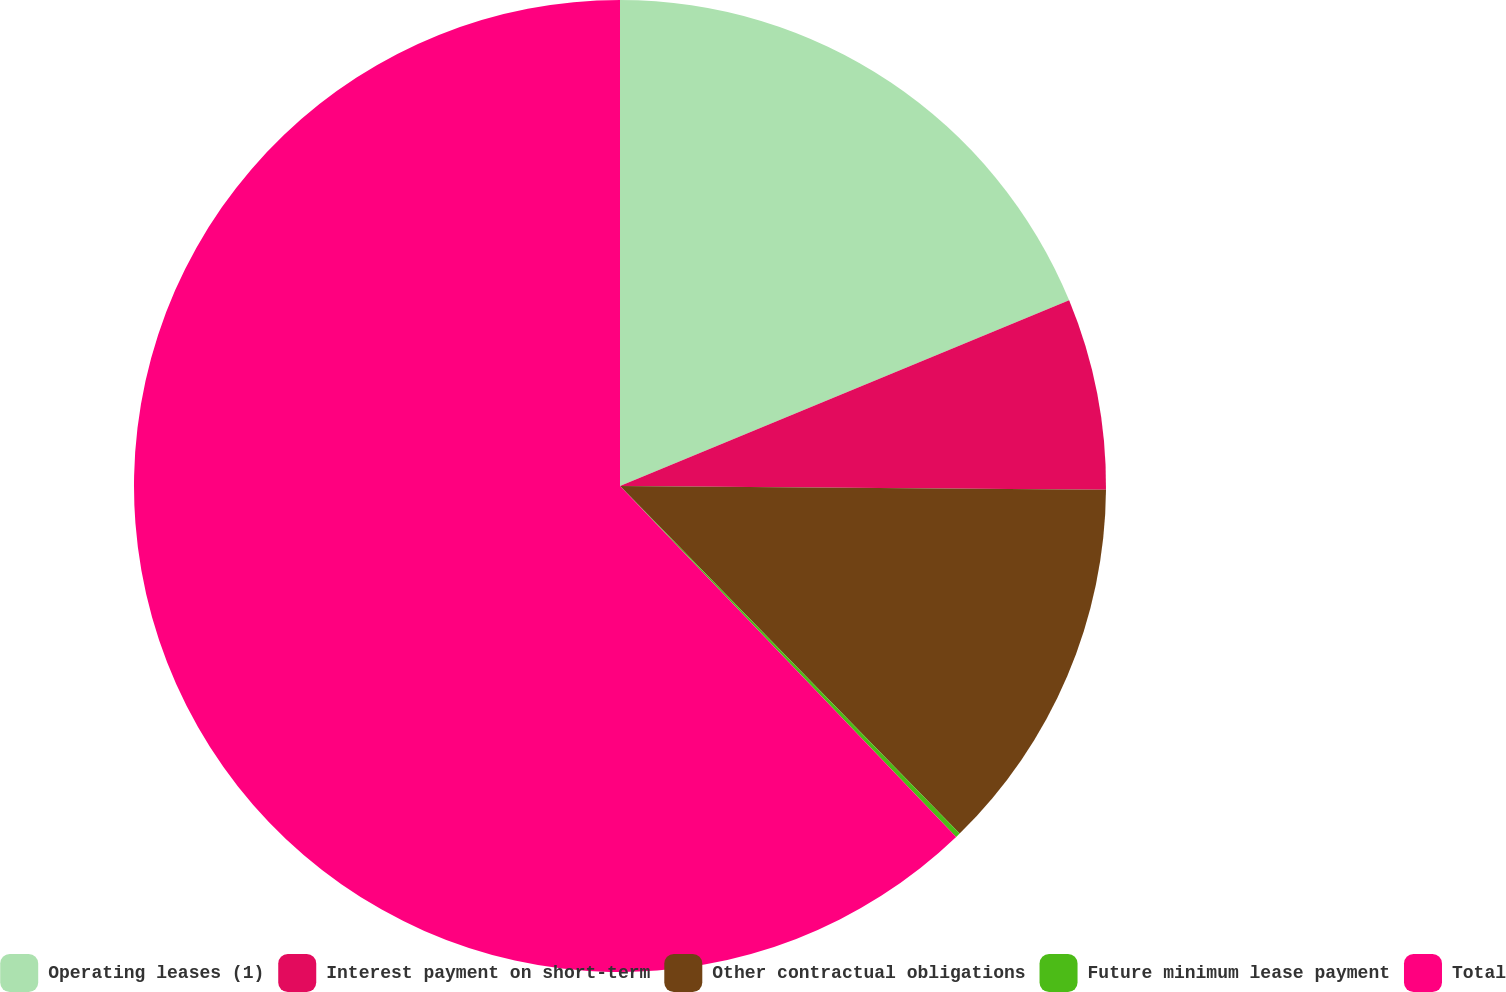Convert chart to OTSL. <chart><loc_0><loc_0><loc_500><loc_500><pie_chart><fcel>Operating leases (1)<fcel>Interest payment on short-term<fcel>Other contractual obligations<fcel>Future minimum lease payment<fcel>Total<nl><fcel>18.76%<fcel>6.36%<fcel>12.56%<fcel>0.16%<fcel>62.15%<nl></chart> 